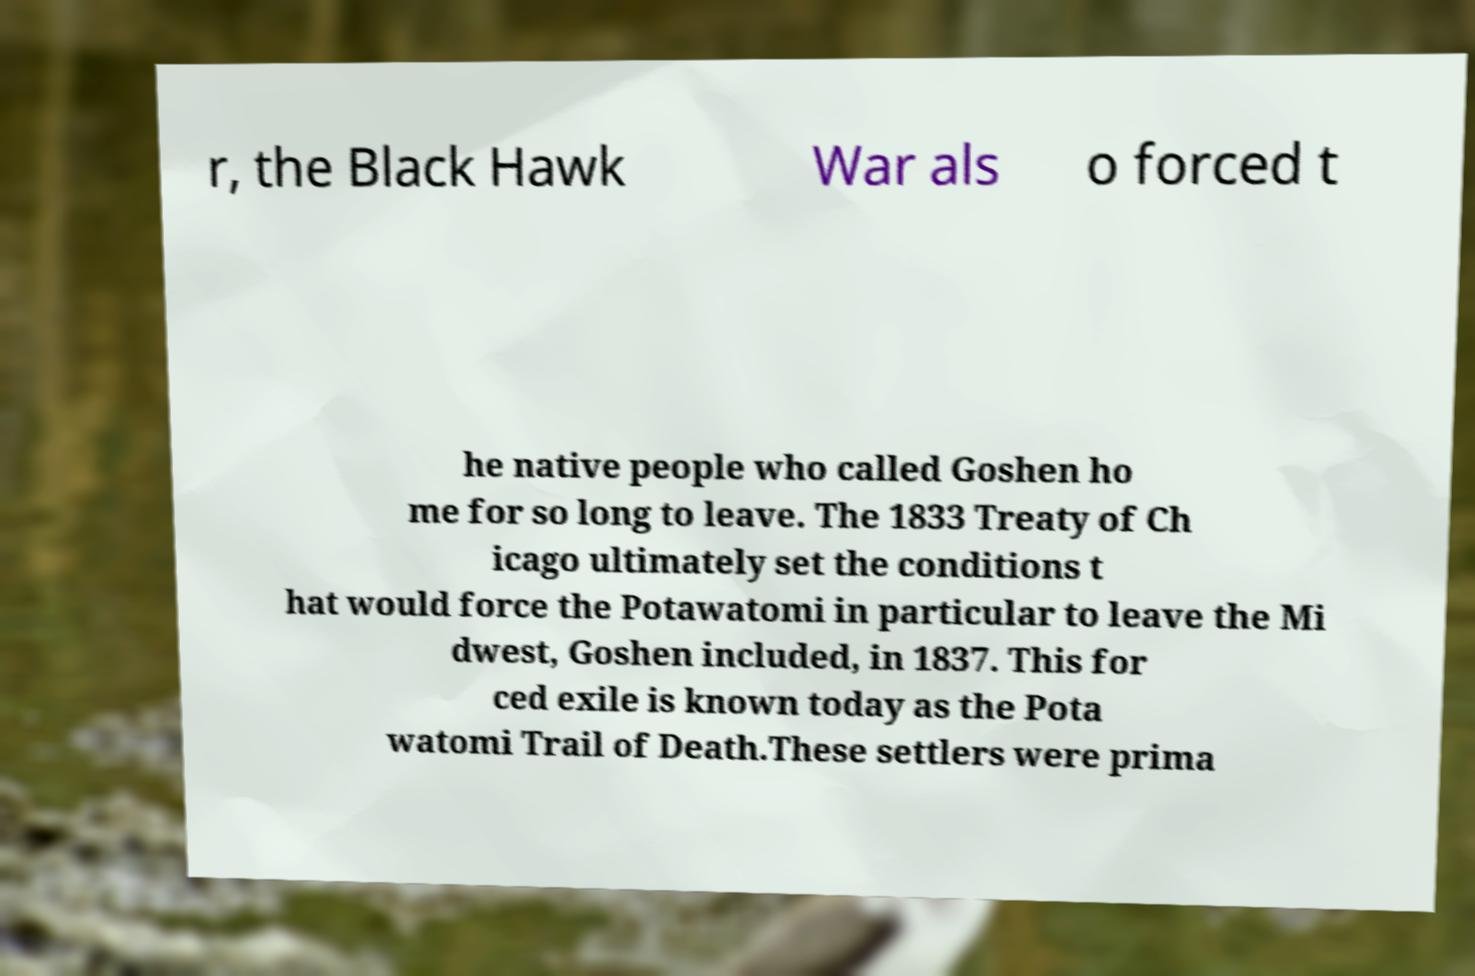Please identify and transcribe the text found in this image. r, the Black Hawk War als o forced t he native people who called Goshen ho me for so long to leave. The 1833 Treaty of Ch icago ultimately set the conditions t hat would force the Potawatomi in particular to leave the Mi dwest, Goshen included, in 1837. This for ced exile is known today as the Pota watomi Trail of Death.These settlers were prima 